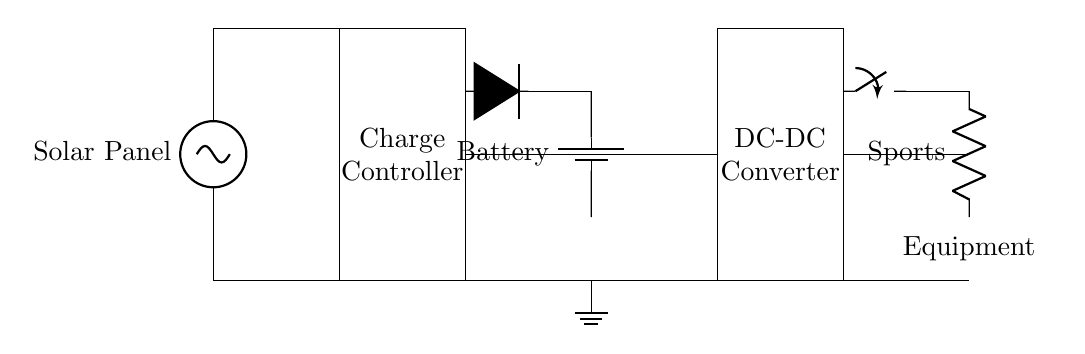What is the main power source for this circuit? The main power source is the solar panel, which generates electricity from sunlight. It is the first component shown at the top of the circuit diagram.
Answer: Solar Panel What component is used to prevent reverse current? A diode is used to prevent reverse current in the circuit; it is placed after the charge controller and before the battery.
Answer: Diode How many major components are in this circuit? The major components in the circuit include the solar panel, charge controller, battery, DC-DC converter, a switch, and the load (sports equipment). Counting these gives a total of six components.
Answer: Six What is the function of the charge controller in this circuit? The charge controller regulates the voltage and current going to the battery, ensuring it is charged properly and preventing overcharging. It is essential for battery protection and efficiency.
Answer: Regulates charging Which component connects the battery to the load? The DC-DC converter connects the battery to the load (sports equipment), as it adjusts the voltage level required by the load. It is the rectangular component placed to the right of the battery in the circuit diagram.
Answer: DC-DC Converter What is the role of the switch in this circuit? The switch allows the user to control the connection of the load to the power source, enabling on/off functionality for the sports equipment. It is situated just before the load in the circuit.
Answer: Control load connection 